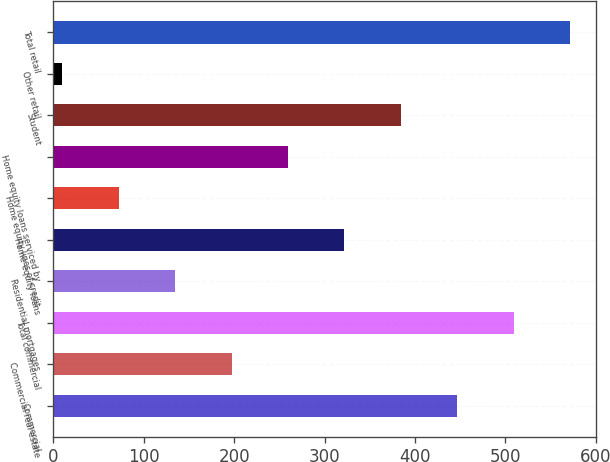Convert chart to OTSL. <chart><loc_0><loc_0><loc_500><loc_500><bar_chart><fcel>Commercial<fcel>Commercial real estate<fcel>Total commercial<fcel>Residential mortgages<fcel>Home equity loans<fcel>Home equity lines of credit<fcel>Home equity loans serviced by<fcel>Student<fcel>Other retail<fcel>Total retail<nl><fcel>446.8<fcel>197.2<fcel>509.2<fcel>134.8<fcel>322<fcel>72.4<fcel>259.6<fcel>384.4<fcel>10<fcel>571.6<nl></chart> 